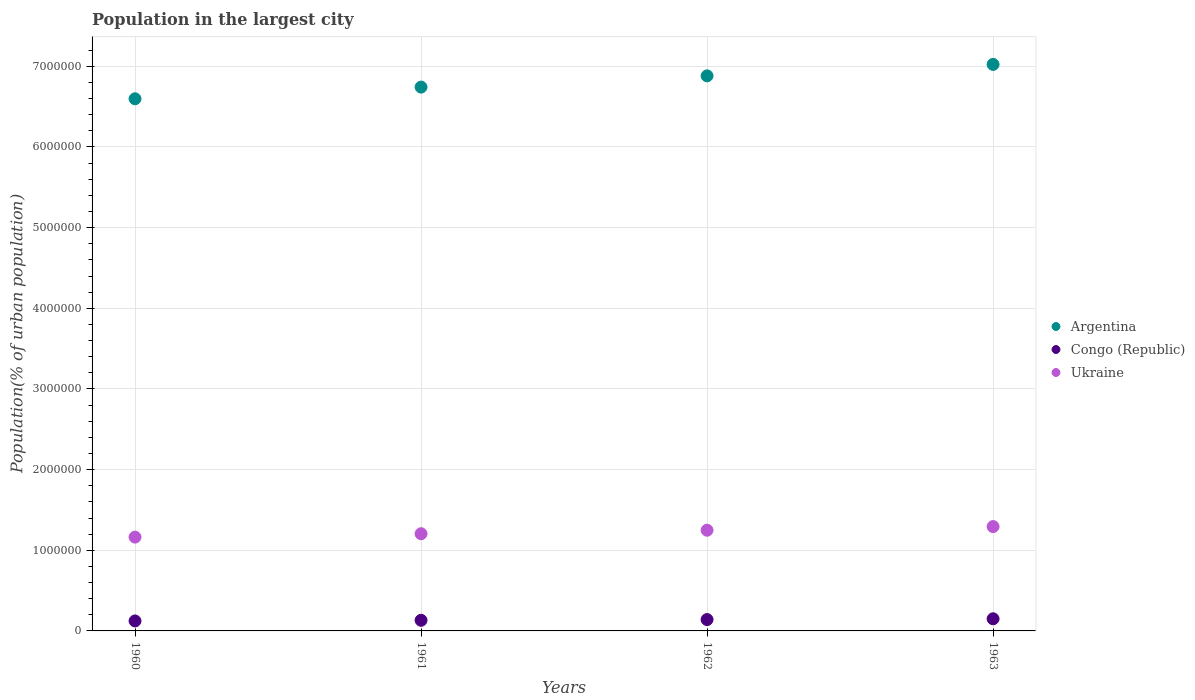What is the population in the largest city in Congo (Republic) in 1962?
Provide a short and direct response. 1.41e+05. Across all years, what is the maximum population in the largest city in Congo (Republic)?
Offer a terse response. 1.50e+05. Across all years, what is the minimum population in the largest city in Ukraine?
Give a very brief answer. 1.16e+06. What is the total population in the largest city in Congo (Republic) in the graph?
Provide a short and direct response. 5.47e+05. What is the difference between the population in the largest city in Congo (Republic) in 1961 and that in 1963?
Offer a terse response. -1.85e+04. What is the difference between the population in the largest city in Ukraine in 1960 and the population in the largest city in Argentina in 1961?
Make the answer very short. -5.58e+06. What is the average population in the largest city in Ukraine per year?
Provide a succinct answer. 1.23e+06. In the year 1960, what is the difference between the population in the largest city in Congo (Republic) and population in the largest city in Ukraine?
Provide a short and direct response. -1.04e+06. In how many years, is the population in the largest city in Ukraine greater than 2400000 %?
Offer a terse response. 0. What is the ratio of the population in the largest city in Argentina in 1960 to that in 1963?
Make the answer very short. 0.94. Is the difference between the population in the largest city in Congo (Republic) in 1961 and 1962 greater than the difference between the population in the largest city in Ukraine in 1961 and 1962?
Offer a terse response. Yes. What is the difference between the highest and the second highest population in the largest city in Argentina?
Keep it short and to the point. 1.42e+05. What is the difference between the highest and the lowest population in the largest city in Argentina?
Keep it short and to the point. 4.26e+05. In how many years, is the population in the largest city in Congo (Republic) greater than the average population in the largest city in Congo (Republic) taken over all years?
Your answer should be very brief. 2. Is the sum of the population in the largest city in Ukraine in 1962 and 1963 greater than the maximum population in the largest city in Argentina across all years?
Offer a terse response. No. Is it the case that in every year, the sum of the population in the largest city in Argentina and population in the largest city in Ukraine  is greater than the population in the largest city in Congo (Republic)?
Your answer should be very brief. Yes. Is the population in the largest city in Congo (Republic) strictly greater than the population in the largest city in Argentina over the years?
Your answer should be very brief. No. Is the population in the largest city in Ukraine strictly less than the population in the largest city in Argentina over the years?
Your answer should be compact. Yes. Does the graph contain grids?
Give a very brief answer. Yes. What is the title of the graph?
Offer a very short reply. Population in the largest city. What is the label or title of the X-axis?
Provide a short and direct response. Years. What is the label or title of the Y-axis?
Your response must be concise. Population(% of urban population). What is the Population(% of urban population) of Argentina in 1960?
Ensure brevity in your answer.  6.60e+06. What is the Population(% of urban population) in Congo (Republic) in 1960?
Provide a succinct answer. 1.24e+05. What is the Population(% of urban population) of Ukraine in 1960?
Offer a very short reply. 1.16e+06. What is the Population(% of urban population) of Argentina in 1961?
Ensure brevity in your answer.  6.74e+06. What is the Population(% of urban population) of Congo (Republic) in 1961?
Offer a terse response. 1.32e+05. What is the Population(% of urban population) in Ukraine in 1961?
Make the answer very short. 1.21e+06. What is the Population(% of urban population) in Argentina in 1962?
Make the answer very short. 6.88e+06. What is the Population(% of urban population) of Congo (Republic) in 1962?
Your answer should be compact. 1.41e+05. What is the Population(% of urban population) in Ukraine in 1962?
Offer a terse response. 1.25e+06. What is the Population(% of urban population) in Argentina in 1963?
Provide a short and direct response. 7.02e+06. What is the Population(% of urban population) in Congo (Republic) in 1963?
Offer a very short reply. 1.50e+05. What is the Population(% of urban population) in Ukraine in 1963?
Provide a succinct answer. 1.29e+06. Across all years, what is the maximum Population(% of urban population) in Argentina?
Keep it short and to the point. 7.02e+06. Across all years, what is the maximum Population(% of urban population) of Congo (Republic)?
Your response must be concise. 1.50e+05. Across all years, what is the maximum Population(% of urban population) in Ukraine?
Keep it short and to the point. 1.29e+06. Across all years, what is the minimum Population(% of urban population) of Argentina?
Provide a succinct answer. 6.60e+06. Across all years, what is the minimum Population(% of urban population) in Congo (Republic)?
Your response must be concise. 1.24e+05. Across all years, what is the minimum Population(% of urban population) of Ukraine?
Provide a succinct answer. 1.16e+06. What is the total Population(% of urban population) of Argentina in the graph?
Your response must be concise. 2.72e+07. What is the total Population(% of urban population) in Congo (Republic) in the graph?
Ensure brevity in your answer.  5.47e+05. What is the total Population(% of urban population) of Ukraine in the graph?
Make the answer very short. 4.91e+06. What is the difference between the Population(% of urban population) of Argentina in 1960 and that in 1961?
Your response must be concise. -1.45e+05. What is the difference between the Population(% of urban population) of Congo (Republic) in 1960 and that in 1961?
Your answer should be compact. -8224. What is the difference between the Population(% of urban population) in Ukraine in 1960 and that in 1961?
Your answer should be compact. -4.20e+04. What is the difference between the Population(% of urban population) in Argentina in 1960 and that in 1962?
Offer a very short reply. -2.84e+05. What is the difference between the Population(% of urban population) in Congo (Republic) in 1960 and that in 1962?
Offer a terse response. -1.71e+04. What is the difference between the Population(% of urban population) of Ukraine in 1960 and that in 1962?
Ensure brevity in your answer.  -8.55e+04. What is the difference between the Population(% of urban population) in Argentina in 1960 and that in 1963?
Make the answer very short. -4.26e+05. What is the difference between the Population(% of urban population) in Congo (Republic) in 1960 and that in 1963?
Your answer should be compact. -2.67e+04. What is the difference between the Population(% of urban population) in Ukraine in 1960 and that in 1963?
Keep it short and to the point. -1.31e+05. What is the difference between the Population(% of urban population) of Argentina in 1961 and that in 1962?
Ensure brevity in your answer.  -1.39e+05. What is the difference between the Population(% of urban population) of Congo (Republic) in 1961 and that in 1962?
Ensure brevity in your answer.  -8884. What is the difference between the Population(% of urban population) in Ukraine in 1961 and that in 1962?
Provide a short and direct response. -4.36e+04. What is the difference between the Population(% of urban population) in Argentina in 1961 and that in 1963?
Your response must be concise. -2.81e+05. What is the difference between the Population(% of urban population) in Congo (Republic) in 1961 and that in 1963?
Ensure brevity in your answer.  -1.85e+04. What is the difference between the Population(% of urban population) of Ukraine in 1961 and that in 1963?
Your response must be concise. -8.87e+04. What is the difference between the Population(% of urban population) of Argentina in 1962 and that in 1963?
Make the answer very short. -1.42e+05. What is the difference between the Population(% of urban population) of Congo (Republic) in 1962 and that in 1963?
Offer a very short reply. -9590. What is the difference between the Population(% of urban population) in Ukraine in 1962 and that in 1963?
Provide a succinct answer. -4.51e+04. What is the difference between the Population(% of urban population) in Argentina in 1960 and the Population(% of urban population) in Congo (Republic) in 1961?
Provide a succinct answer. 6.47e+06. What is the difference between the Population(% of urban population) in Argentina in 1960 and the Population(% of urban population) in Ukraine in 1961?
Give a very brief answer. 5.39e+06. What is the difference between the Population(% of urban population) of Congo (Republic) in 1960 and the Population(% of urban population) of Ukraine in 1961?
Your answer should be compact. -1.08e+06. What is the difference between the Population(% of urban population) in Argentina in 1960 and the Population(% of urban population) in Congo (Republic) in 1962?
Keep it short and to the point. 6.46e+06. What is the difference between the Population(% of urban population) in Argentina in 1960 and the Population(% of urban population) in Ukraine in 1962?
Give a very brief answer. 5.35e+06. What is the difference between the Population(% of urban population) in Congo (Republic) in 1960 and the Population(% of urban population) in Ukraine in 1962?
Your response must be concise. -1.12e+06. What is the difference between the Population(% of urban population) in Argentina in 1960 and the Population(% of urban population) in Congo (Republic) in 1963?
Keep it short and to the point. 6.45e+06. What is the difference between the Population(% of urban population) of Argentina in 1960 and the Population(% of urban population) of Ukraine in 1963?
Ensure brevity in your answer.  5.30e+06. What is the difference between the Population(% of urban population) in Congo (Republic) in 1960 and the Population(% of urban population) in Ukraine in 1963?
Your response must be concise. -1.17e+06. What is the difference between the Population(% of urban population) in Argentina in 1961 and the Population(% of urban population) in Congo (Republic) in 1962?
Your answer should be compact. 6.60e+06. What is the difference between the Population(% of urban population) of Argentina in 1961 and the Population(% of urban population) of Ukraine in 1962?
Ensure brevity in your answer.  5.49e+06. What is the difference between the Population(% of urban population) in Congo (Republic) in 1961 and the Population(% of urban population) in Ukraine in 1962?
Your answer should be very brief. -1.12e+06. What is the difference between the Population(% of urban population) of Argentina in 1961 and the Population(% of urban population) of Congo (Republic) in 1963?
Your response must be concise. 6.59e+06. What is the difference between the Population(% of urban population) in Argentina in 1961 and the Population(% of urban population) in Ukraine in 1963?
Make the answer very short. 5.45e+06. What is the difference between the Population(% of urban population) of Congo (Republic) in 1961 and the Population(% of urban population) of Ukraine in 1963?
Ensure brevity in your answer.  -1.16e+06. What is the difference between the Population(% of urban population) of Argentina in 1962 and the Population(% of urban population) of Congo (Republic) in 1963?
Give a very brief answer. 6.73e+06. What is the difference between the Population(% of urban population) of Argentina in 1962 and the Population(% of urban population) of Ukraine in 1963?
Make the answer very short. 5.59e+06. What is the difference between the Population(% of urban population) in Congo (Republic) in 1962 and the Population(% of urban population) in Ukraine in 1963?
Offer a terse response. -1.15e+06. What is the average Population(% of urban population) of Argentina per year?
Keep it short and to the point. 6.81e+06. What is the average Population(% of urban population) of Congo (Republic) per year?
Make the answer very short. 1.37e+05. What is the average Population(% of urban population) in Ukraine per year?
Your answer should be compact. 1.23e+06. In the year 1960, what is the difference between the Population(% of urban population) of Argentina and Population(% of urban population) of Congo (Republic)?
Ensure brevity in your answer.  6.47e+06. In the year 1960, what is the difference between the Population(% of urban population) in Argentina and Population(% of urban population) in Ukraine?
Ensure brevity in your answer.  5.43e+06. In the year 1960, what is the difference between the Population(% of urban population) in Congo (Republic) and Population(% of urban population) in Ukraine?
Keep it short and to the point. -1.04e+06. In the year 1961, what is the difference between the Population(% of urban population) in Argentina and Population(% of urban population) in Congo (Republic)?
Ensure brevity in your answer.  6.61e+06. In the year 1961, what is the difference between the Population(% of urban population) in Argentina and Population(% of urban population) in Ukraine?
Offer a terse response. 5.54e+06. In the year 1961, what is the difference between the Population(% of urban population) of Congo (Republic) and Population(% of urban population) of Ukraine?
Your response must be concise. -1.07e+06. In the year 1962, what is the difference between the Population(% of urban population) of Argentina and Population(% of urban population) of Congo (Republic)?
Provide a succinct answer. 6.74e+06. In the year 1962, what is the difference between the Population(% of urban population) of Argentina and Population(% of urban population) of Ukraine?
Offer a very short reply. 5.63e+06. In the year 1962, what is the difference between the Population(% of urban population) in Congo (Republic) and Population(% of urban population) in Ukraine?
Keep it short and to the point. -1.11e+06. In the year 1963, what is the difference between the Population(% of urban population) of Argentina and Population(% of urban population) of Congo (Republic)?
Your answer should be very brief. 6.87e+06. In the year 1963, what is the difference between the Population(% of urban population) in Argentina and Population(% of urban population) in Ukraine?
Make the answer very short. 5.73e+06. In the year 1963, what is the difference between the Population(% of urban population) in Congo (Republic) and Population(% of urban population) in Ukraine?
Make the answer very short. -1.14e+06. What is the ratio of the Population(% of urban population) in Argentina in 1960 to that in 1961?
Give a very brief answer. 0.98. What is the ratio of the Population(% of urban population) in Congo (Republic) in 1960 to that in 1961?
Provide a short and direct response. 0.94. What is the ratio of the Population(% of urban population) in Ukraine in 1960 to that in 1961?
Make the answer very short. 0.97. What is the ratio of the Population(% of urban population) of Argentina in 1960 to that in 1962?
Make the answer very short. 0.96. What is the ratio of the Population(% of urban population) of Congo (Republic) in 1960 to that in 1962?
Your response must be concise. 0.88. What is the ratio of the Population(% of urban population) of Ukraine in 1960 to that in 1962?
Offer a terse response. 0.93. What is the ratio of the Population(% of urban population) in Argentina in 1960 to that in 1963?
Provide a succinct answer. 0.94. What is the ratio of the Population(% of urban population) in Congo (Republic) in 1960 to that in 1963?
Your answer should be very brief. 0.82. What is the ratio of the Population(% of urban population) of Ukraine in 1960 to that in 1963?
Provide a succinct answer. 0.9. What is the ratio of the Population(% of urban population) in Argentina in 1961 to that in 1962?
Your response must be concise. 0.98. What is the ratio of the Population(% of urban population) in Congo (Republic) in 1961 to that in 1962?
Make the answer very short. 0.94. What is the ratio of the Population(% of urban population) in Ukraine in 1961 to that in 1962?
Offer a terse response. 0.97. What is the ratio of the Population(% of urban population) in Argentina in 1961 to that in 1963?
Make the answer very short. 0.96. What is the ratio of the Population(% of urban population) in Congo (Republic) in 1961 to that in 1963?
Ensure brevity in your answer.  0.88. What is the ratio of the Population(% of urban population) of Ukraine in 1961 to that in 1963?
Offer a terse response. 0.93. What is the ratio of the Population(% of urban population) in Argentina in 1962 to that in 1963?
Offer a very short reply. 0.98. What is the ratio of the Population(% of urban population) in Congo (Republic) in 1962 to that in 1963?
Give a very brief answer. 0.94. What is the ratio of the Population(% of urban population) in Ukraine in 1962 to that in 1963?
Keep it short and to the point. 0.97. What is the difference between the highest and the second highest Population(% of urban population) of Argentina?
Your answer should be compact. 1.42e+05. What is the difference between the highest and the second highest Population(% of urban population) in Congo (Republic)?
Ensure brevity in your answer.  9590. What is the difference between the highest and the second highest Population(% of urban population) of Ukraine?
Offer a very short reply. 4.51e+04. What is the difference between the highest and the lowest Population(% of urban population) of Argentina?
Provide a succinct answer. 4.26e+05. What is the difference between the highest and the lowest Population(% of urban population) in Congo (Republic)?
Ensure brevity in your answer.  2.67e+04. What is the difference between the highest and the lowest Population(% of urban population) in Ukraine?
Give a very brief answer. 1.31e+05. 